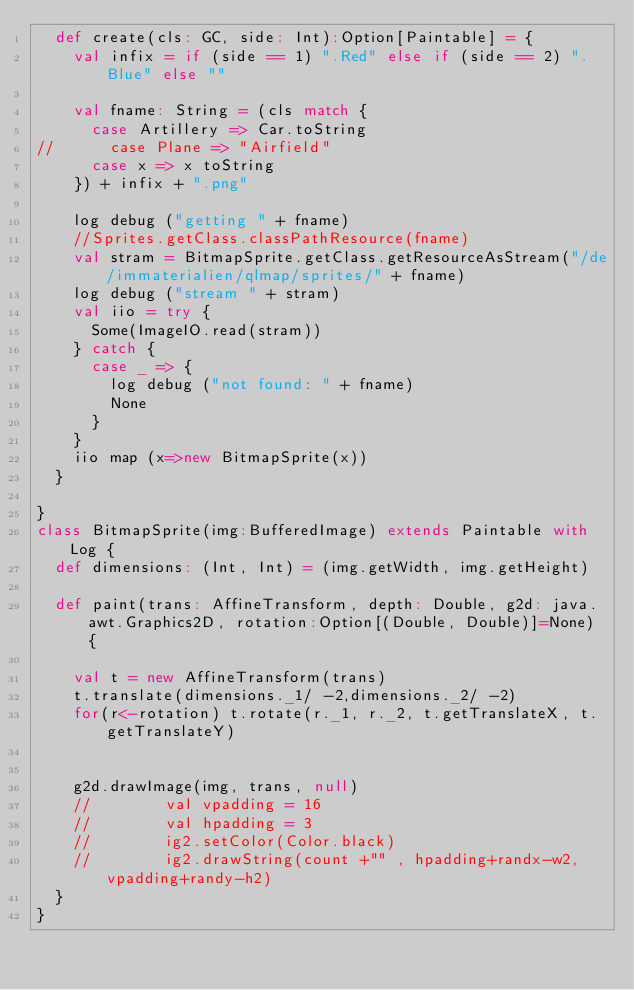<code> <loc_0><loc_0><loc_500><loc_500><_Scala_>  def create(cls: GC, side: Int):Option[Paintable] = {
    val infix = if (side == 1) ".Red" else if (side == 2) ".Blue" else ""
 
    val fname: String = (cls match {
      case Artillery => Car.toString
//      case Plane => "Airfield"
      case x => x toString
    }) + infix + ".png"

    log debug ("getting " + fname)
    //Sprites.getClass.classPathResource(fname)
    val stram = BitmapSprite.getClass.getResourceAsStream("/de/immaterialien/qlmap/sprites/" + fname)
    log debug ("stream " + stram)
    val iio = try {
      Some(ImageIO.read(stram))
    } catch {
      case _ => {
        log debug ("not found: " + fname)
        None
      }
    }
    iio map (x=>new BitmapSprite(x))
  }

}
class BitmapSprite(img:BufferedImage) extends Paintable with Log {
  def dimensions: (Int, Int) = (img.getWidth, img.getHeight)

  def paint(trans: AffineTransform, depth: Double, g2d: java.awt.Graphics2D, rotation:Option[(Double, Double)]=None) {
    
    val t = new AffineTransform(trans)
    t.translate(dimensions._1/ -2,dimensions._2/ -2)
    for(r<-rotation) t.rotate(r._1, r._2, t.getTranslateX, t.getTranslateY)
    
    
    g2d.drawImage(img, trans, null)
    //        val vpadding = 16
    //        val hpadding = 3
    //        ig2.setColor(Color.black)
    //        ig2.drawString(count +"" , hpadding+randx-w2, vpadding+randy-h2)
  }
}</code> 